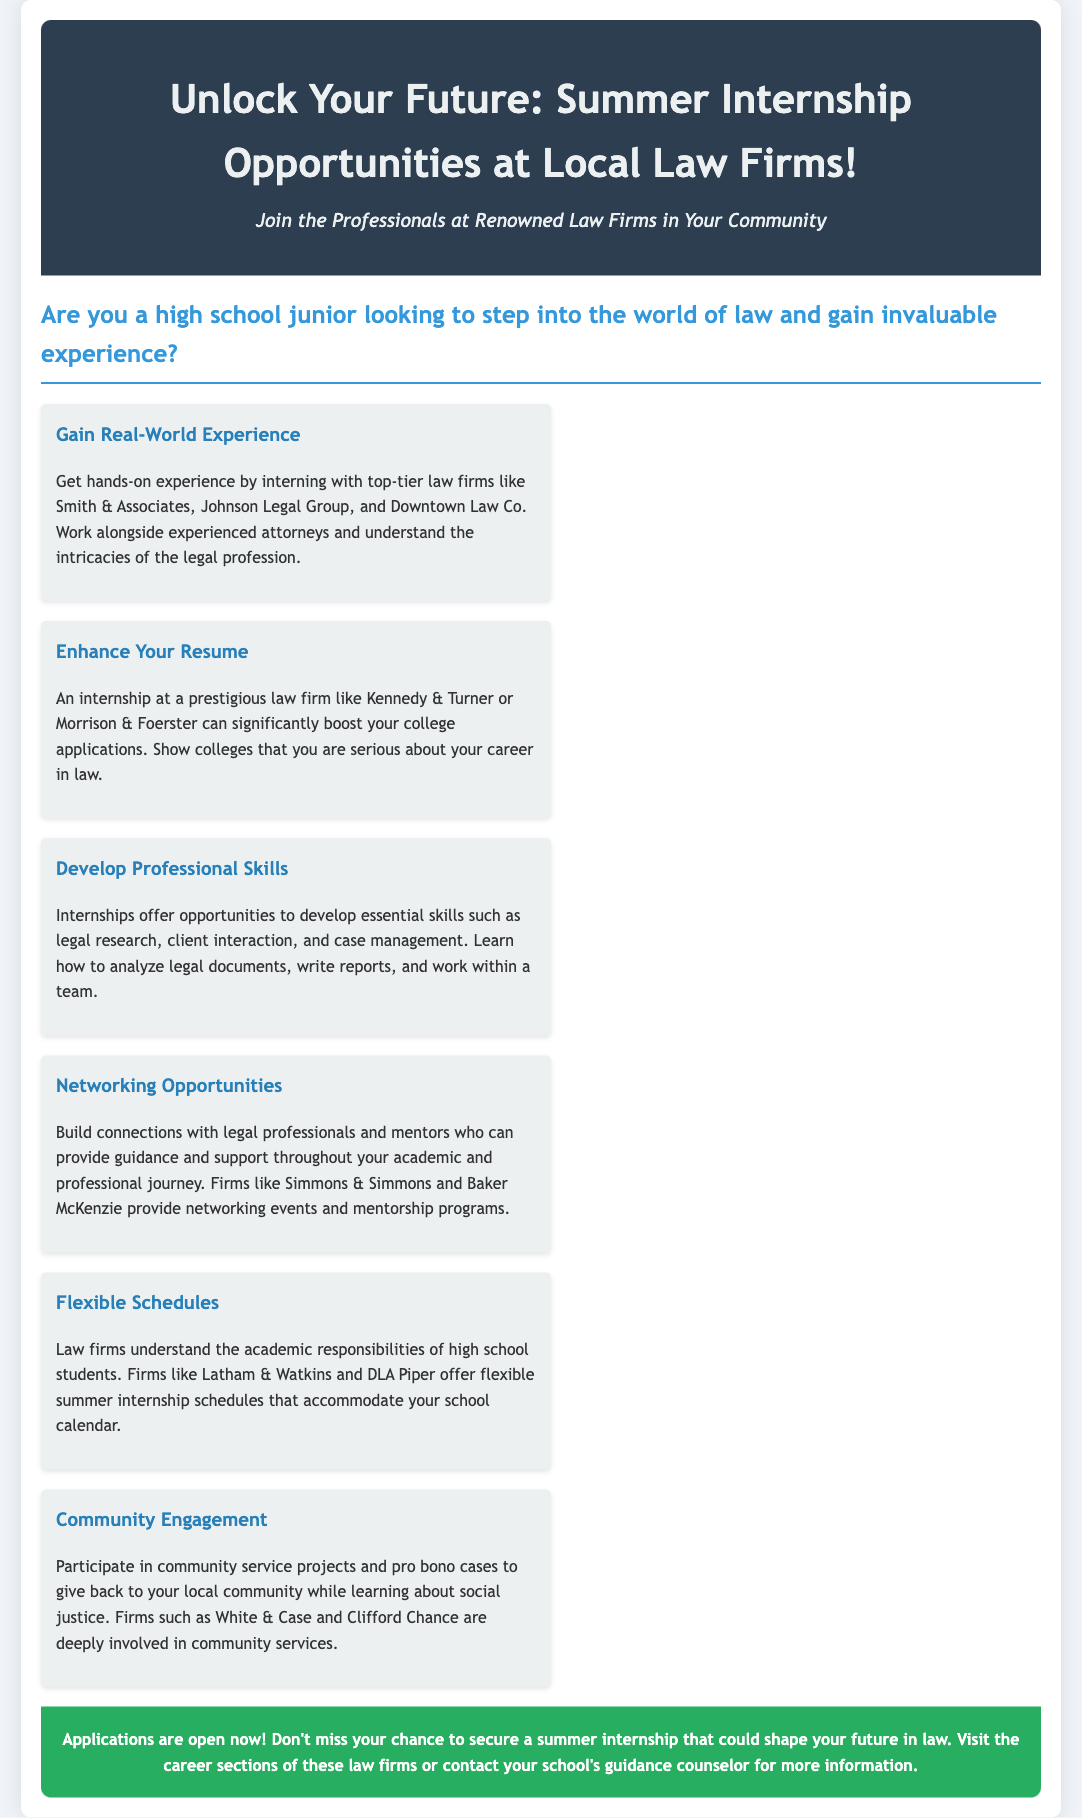What is the title of the advertisement? The title of the advertisement is prominently displayed at the top of the document.
Answer: Unlock Your Future: Summer Internship Opportunities at Local Law Firms! Who are some of the law firms mentioned for internships? The document lists various law firms where internships are available.
Answer: Smith & Associates, Johnson Legal Group, Downtown Law Co., Kennedy & Turner, Morrison & Foerster What skill can you develop through the internships? The document outlines specific skills that can be developed during the internship experience.
Answer: Legal research What is a benefit of an internship mentioned in the document? The document highlights multiple benefits of participating in an internship at a law firm.
Answer: Enhance Your Resume Which firms are known for providing networking opportunities? The document specifies law firms that offer networking events and programs for interns.
Answer: Simmons & Simmons, Baker McKenzie What is emphasized regarding the internship schedules? The document addresses how the internship schedules are designed for students.
Answer: Flexible Schedules What type of projects do the law firms engage in for community involvement? The advertisement includes a section about how firms contribute to the community.
Answer: Community service projects What is the call to action at the end of the advertisement? The document concludes with an encouragement to take action regarding internship applications.
Answer: Applications are open now! 